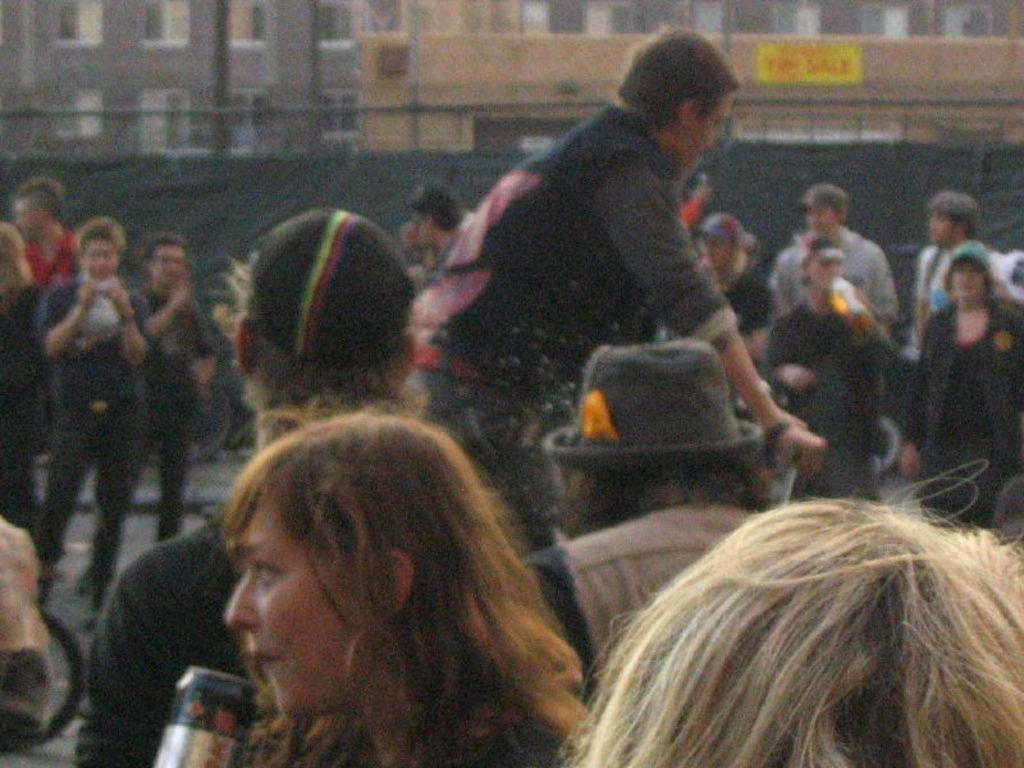What is located at the bottom of the image? There is a crowd at the bottom of the image. What can be seen in the image besides the crowd? There is a fence in the image. What is the appearance of the fence? The fence has a black color curtain. What is visible in the background of the image? There is a building in the background of the image. How many jellyfish are swimming in the crowd in the image? There are no jellyfish present in the image; it features a crowd and a fence with a black curtain. What hobbies do the people in the crowd have, based on the image? The image does not provide information about the hobbies of the people in the crowd. 